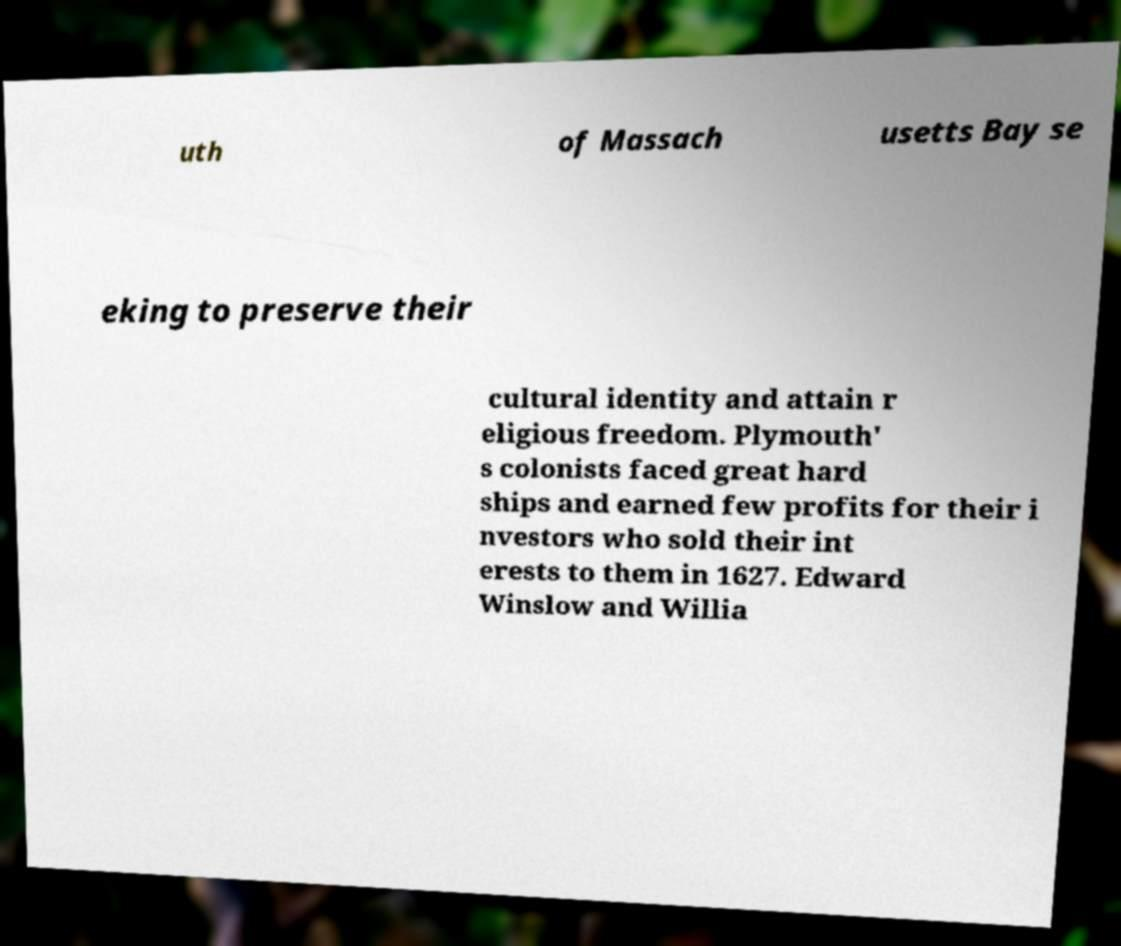Could you assist in decoding the text presented in this image and type it out clearly? uth of Massach usetts Bay se eking to preserve their cultural identity and attain r eligious freedom. Plymouth' s colonists faced great hard ships and earned few profits for their i nvestors who sold their int erests to them in 1627. Edward Winslow and Willia 